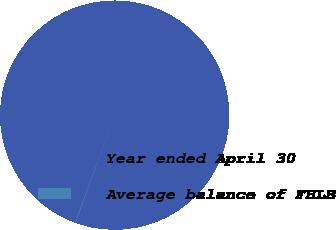<chart> <loc_0><loc_0><loc_500><loc_500><pie_chart><fcel>Year ended April 30<fcel>Average balance of FHLB<nl><fcel>99.9%<fcel>0.1%<nl></chart> 